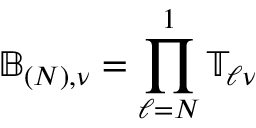Convert formula to latex. <formula><loc_0><loc_0><loc_500><loc_500>\mathbb { B } _ { ( N ) , \nu } = \prod _ { \ell = N } ^ { 1 } \mathbb { T } _ { \ell \nu }</formula> 